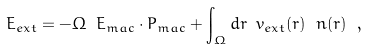<formula> <loc_0><loc_0><loc_500><loc_500>E _ { e x t } = - \Omega \ { E _ { \sl m a c } } \cdot { P } _ { \sl m a c } + \int _ { \Omega } d { r } \ v _ { e x t } ( { r } ) \ n ( { r } ) \ ,</formula> 